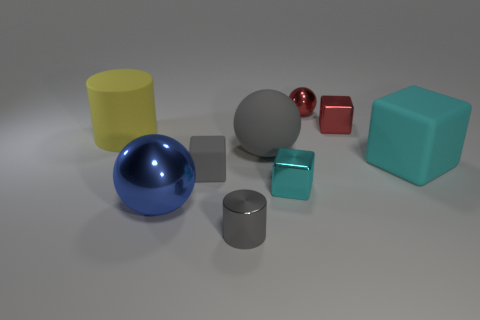Could you infer the possible materials these objects might be made of based on their appearance? Based on their appearance, the objects might be made from various materials. The spheres and cylinders, with their reflective surfaces, suggest metallic properties, perhaps steel or aluminum. The cubes, with a matte finish, could be made of plastic or painted wood, as they do not exhibit the same level of shine. 